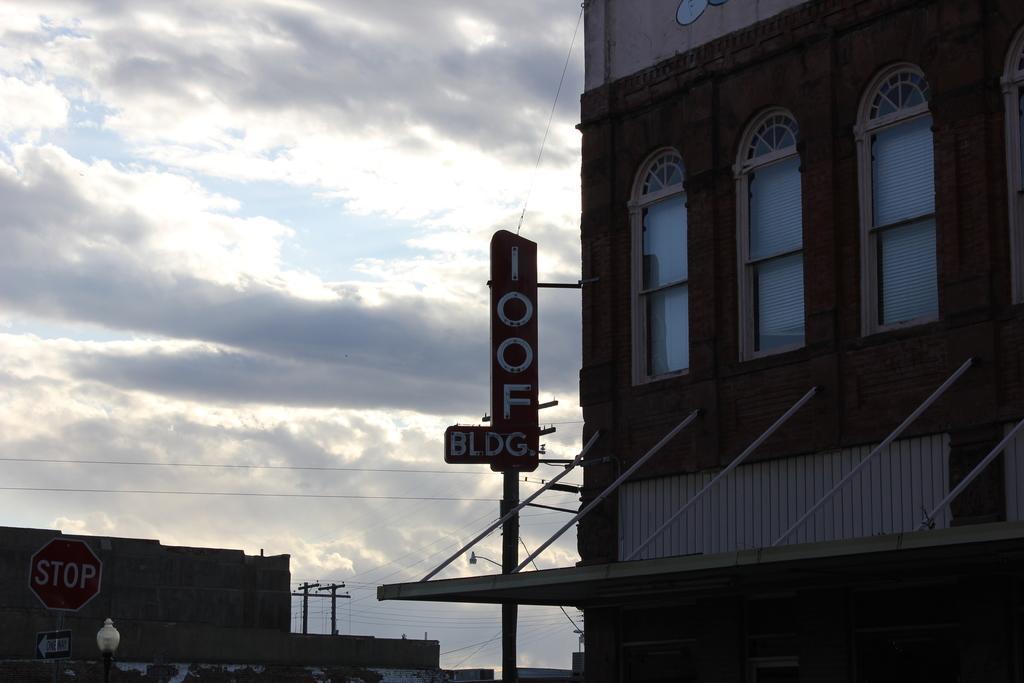In one or two sentences, can you explain what this image depicts? In this picture we can see a name board, sign boards, poles, wires, buildings, windows, light and in the background we can see the sky with clouds. 